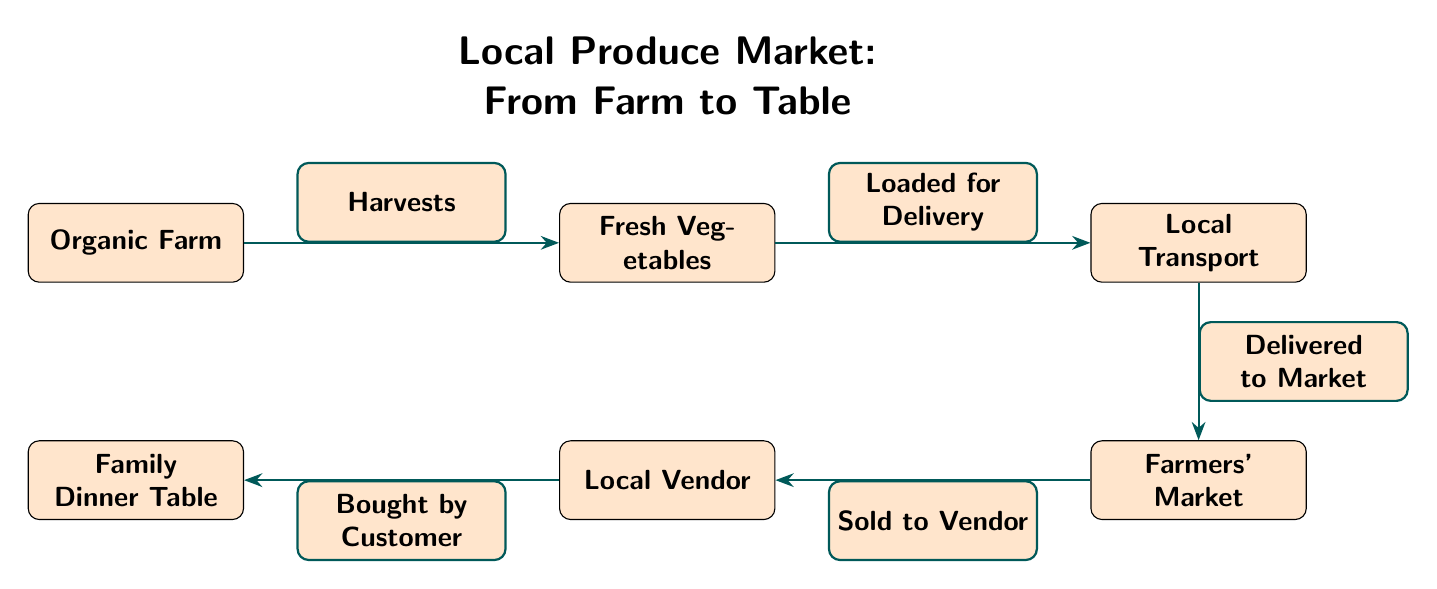What is the first node in the diagram? The first node in the diagram is labeled "Organic Farm," which represents the starting point of the food chain.
Answer: Organic Farm How many nodes are in the diagram? The diagram contains a total of six nodes: Organic Farm, Fresh Vegetables, Local Transport, Farmers' Market, Local Vendor, and Family Dinner Table.
Answer: 6 What does the Local Vendor node represent? The Local Vendor node represents the entity that sells the produce after it has arrived at the Farmers' Market, acting as an intermediary between the market and the customer.
Answer: Local Vendor What action occurs between Fresh Vegetables and Local Transport? The action that occurs between Fresh Vegetables and Local Transport is labeled "Loaded for Delivery," indicating the process where vegetables are prepared for delivery.
Answer: Loaded for Delivery Which node comes after the Farmers' Market in the flow? The node that comes after the Farmers' Market in the flow is the Local Vendor, indicating the relationship where the vendor purchases products from the market.
Answer: Local Vendor What is the relationship between the Organic Farm and Fresh Vegetables? The relationship is indicated by the term "Harvests," showing that the farm produces and collects vegetables from the land.
Answer: Harvests What is sold to the Local Vendor? The product sold to the Local Vendor is the produce from the Farmers' Market, which consists of fresh vegetables.
Answer: Fresh Vegetables What is the final destination of the food chain represented in this diagram? The final destination of the food chain is the Family Dinner Table, where the purchased food is consumed by the family.
Answer: Family Dinner Table What label describes the delivery action to the Farmers' Market? The label describing the delivery action to the Farmers' Market is "Delivered to Market," which signifies the transportation step in the supply chain.
Answer: Delivered to Market What do the arrows in the diagram represent? The arrows in the diagram represent the flow of produce and the sequence of actions from the Organic Farm to the Family Dinner Table.
Answer: Flow of produce 